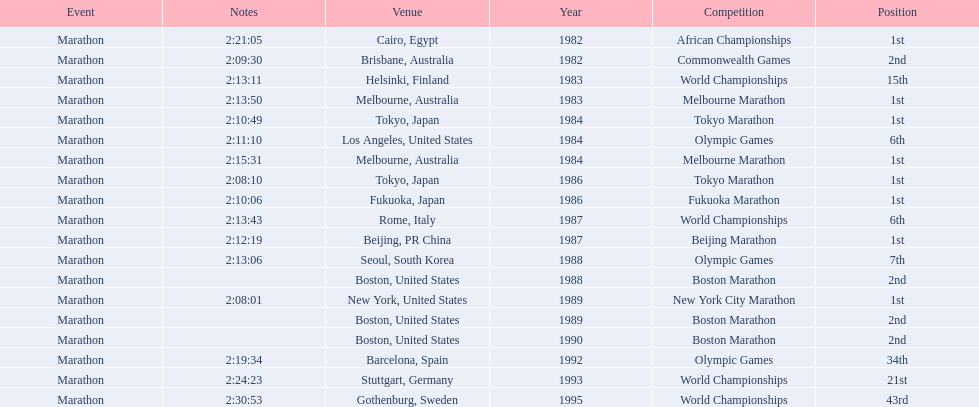What are all of the juma ikangaa competitions? African Championships, Commonwealth Games, World Championships, Melbourne Marathon, Tokyo Marathon, Olympic Games, Melbourne Marathon, Tokyo Marathon, Fukuoka Marathon, World Championships, Beijing Marathon, Olympic Games, Boston Marathon, New York City Marathon, Boston Marathon, Boston Marathon, Olympic Games, World Championships, World Championships. Which of these competitions did not take place in the united states? African Championships, Commonwealth Games, World Championships, Melbourne Marathon, Tokyo Marathon, Melbourne Marathon, Tokyo Marathon, Fukuoka Marathon, World Championships, Beijing Marathon, Olympic Games, Olympic Games, World Championships, World Championships. Out of these, which of them took place in asia? Tokyo Marathon, Tokyo Marathon, Fukuoka Marathon, Beijing Marathon, Olympic Games. Which of the remaining competitions took place in china? Beijing Marathon. 